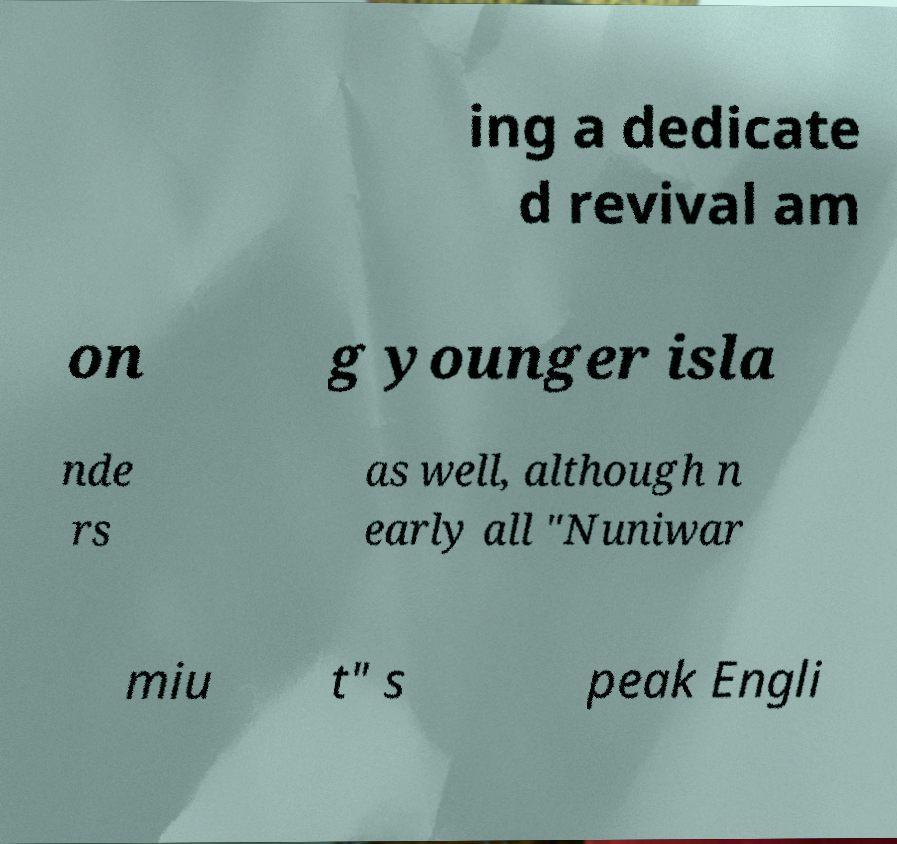For documentation purposes, I need the text within this image transcribed. Could you provide that? ing a dedicate d revival am on g younger isla nde rs as well, although n early all "Nuniwar miu t" s peak Engli 